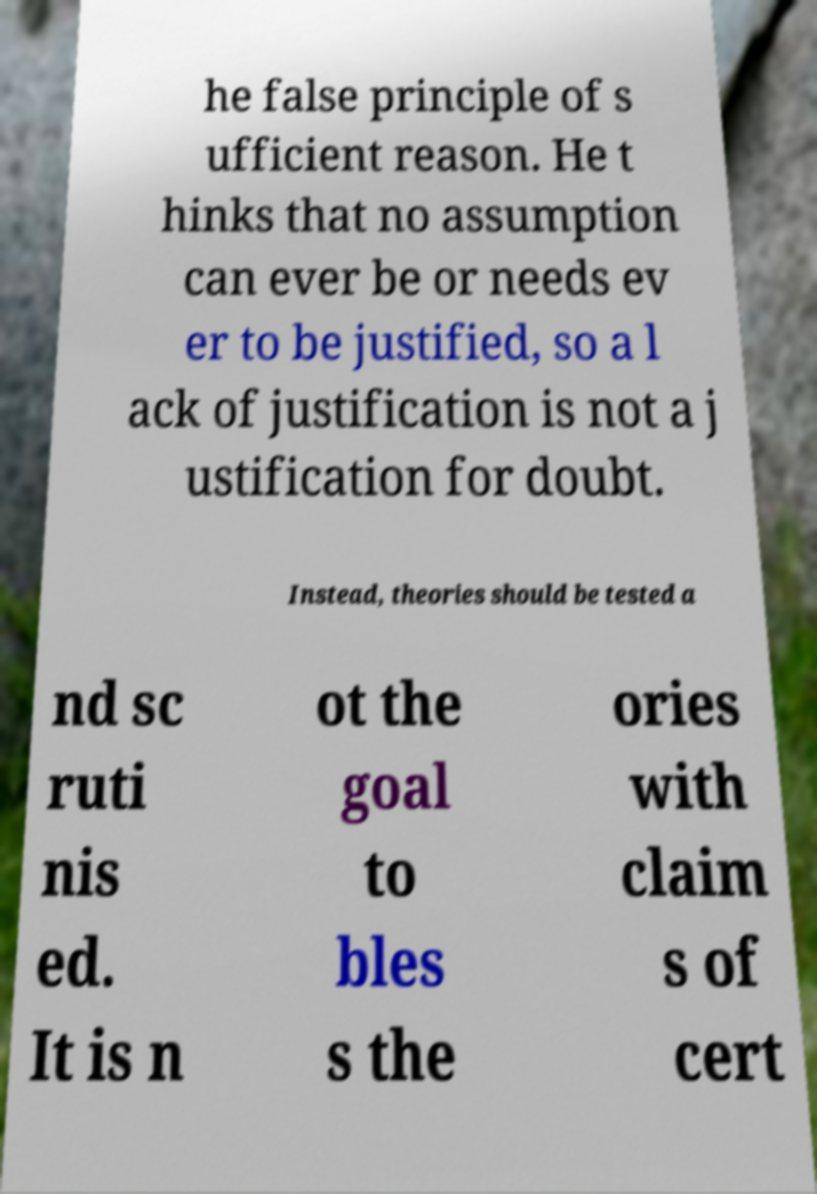Could you assist in decoding the text presented in this image and type it out clearly? he false principle of s ufficient reason. He t hinks that no assumption can ever be or needs ev er to be justified, so a l ack of justification is not a j ustification for doubt. Instead, theories should be tested a nd sc ruti nis ed. It is n ot the goal to bles s the ories with claim s of cert 